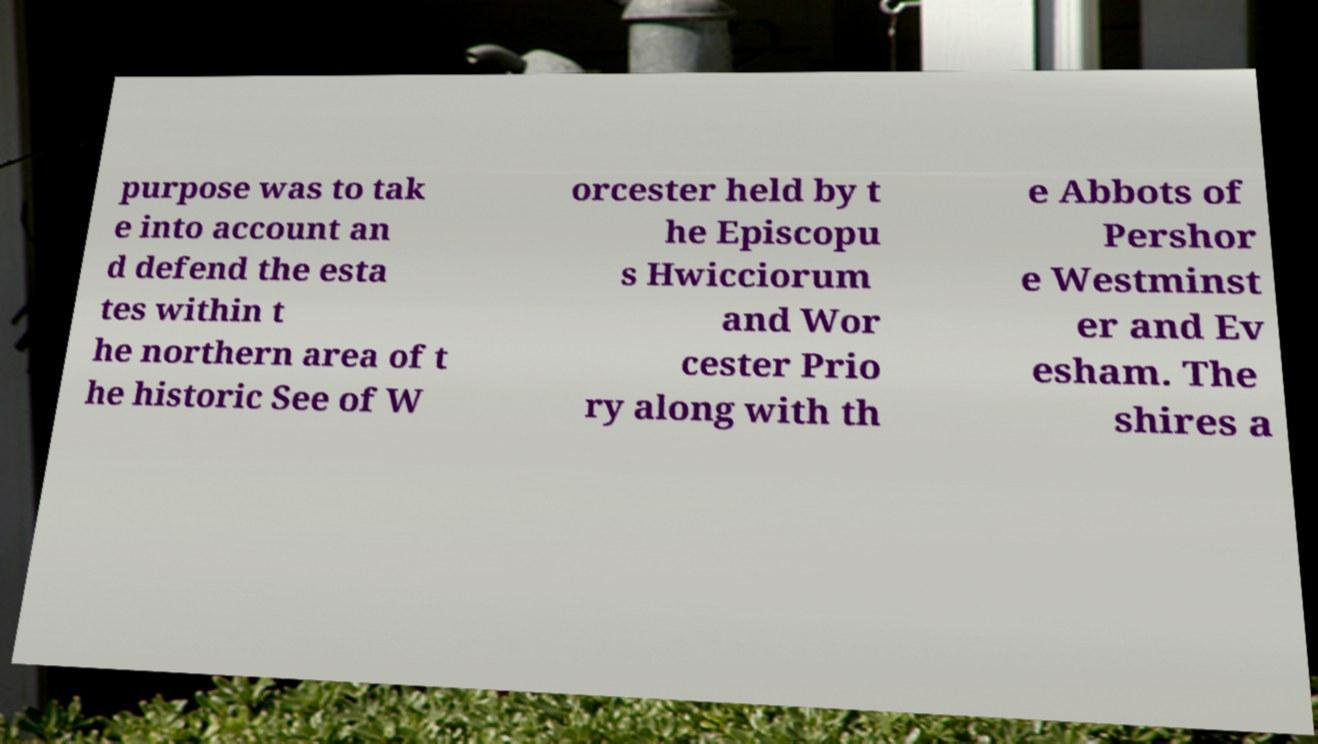There's text embedded in this image that I need extracted. Can you transcribe it verbatim? purpose was to tak e into account an d defend the esta tes within t he northern area of t he historic See of W orcester held by t he Episcopu s Hwicciorum and Wor cester Prio ry along with th e Abbots of Pershor e Westminst er and Ev esham. The shires a 